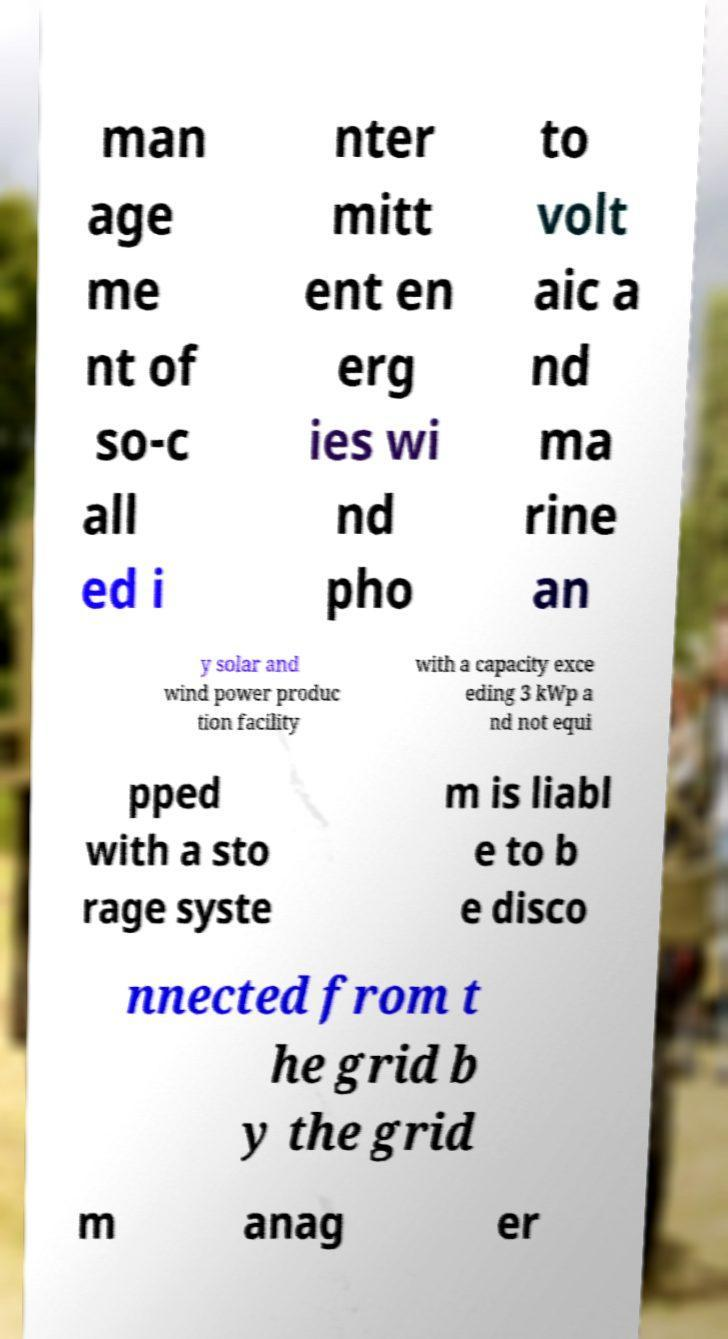There's text embedded in this image that I need extracted. Can you transcribe it verbatim? man age me nt of so-c all ed i nter mitt ent en erg ies wi nd pho to volt aic a nd ma rine an y solar and wind power produc tion facility with a capacity exce eding 3 kWp a nd not equi pped with a sto rage syste m is liabl e to b e disco nnected from t he grid b y the grid m anag er 